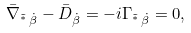Convert formula to latex. <formula><loc_0><loc_0><loc_500><loc_500>\bar { \nabla } _ { { \tilde { ^ { * } } } \, \dot { \beta } } - \bar { D } _ { \dot { \beta } } = - i \Gamma _ { { \tilde { ^ { * } } } \, \dot { \beta } } = 0 ,</formula> 